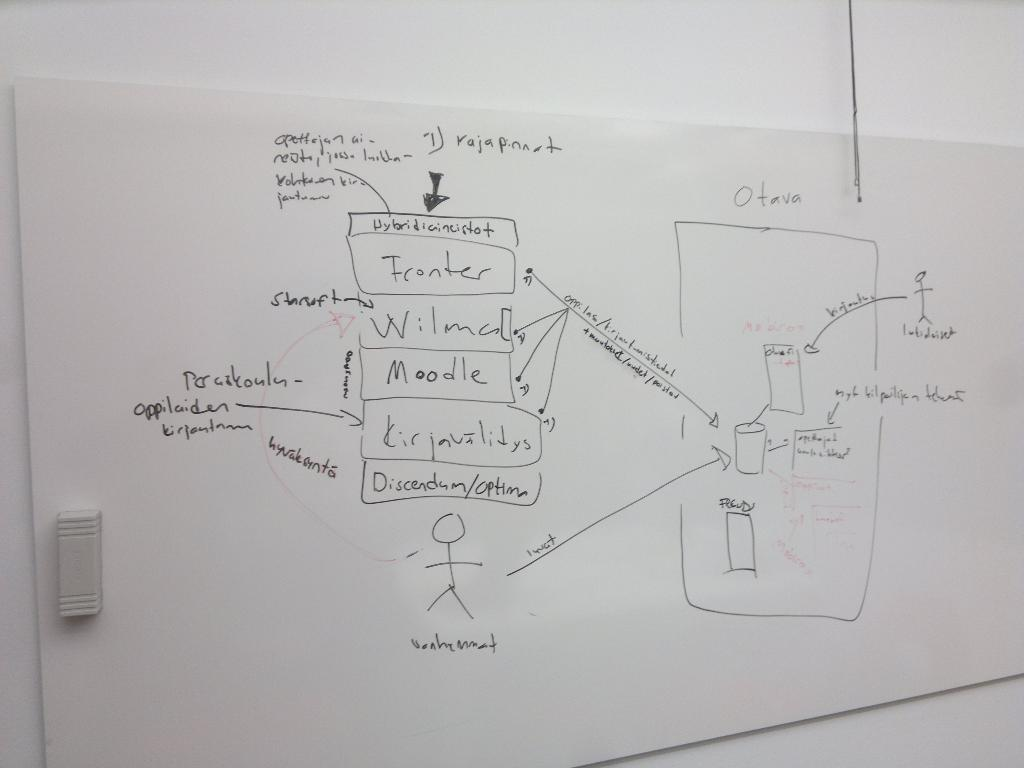<image>
Give a short and clear explanation of the subsequent image. A chart is drawn on a white board, the right area labeled Otava. 